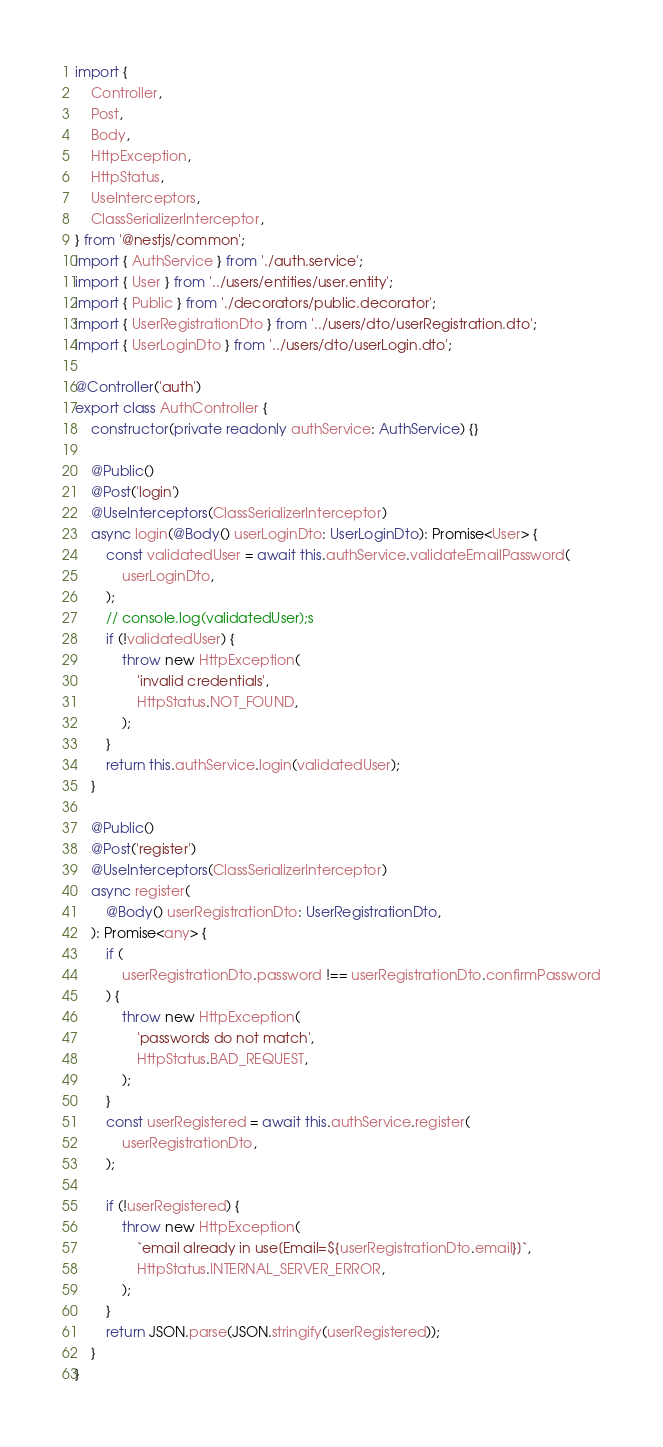<code> <loc_0><loc_0><loc_500><loc_500><_TypeScript_>import {
    Controller,
    Post,
    Body,
    HttpException,
    HttpStatus,
    UseInterceptors,
    ClassSerializerInterceptor,
} from '@nestjs/common';
import { AuthService } from './auth.service';
import { User } from '../users/entities/user.entity';
import { Public } from './decorators/public.decorator';
import { UserRegistrationDto } from '../users/dto/userRegistration.dto';
import { UserLoginDto } from '../users/dto/userLogin.dto';

@Controller('auth')
export class AuthController {
    constructor(private readonly authService: AuthService) {}

    @Public()
    @Post('login')
    @UseInterceptors(ClassSerializerInterceptor)
    async login(@Body() userLoginDto: UserLoginDto): Promise<User> {
        const validatedUser = await this.authService.validateEmailPassword(
            userLoginDto,
        );
        // console.log(validatedUser);s
        if (!validatedUser) {
            throw new HttpException(
                'invalid credentials',
                HttpStatus.NOT_FOUND,
            );
        }
        return this.authService.login(validatedUser);
    }

    @Public()
    @Post('register')
    @UseInterceptors(ClassSerializerInterceptor)
    async register(
        @Body() userRegistrationDto: UserRegistrationDto,
    ): Promise<any> {
        if (
            userRegistrationDto.password !== userRegistrationDto.confirmPassword
        ) {
            throw new HttpException(
                'passwords do not match',
                HttpStatus.BAD_REQUEST,
            );
        }
        const userRegistered = await this.authService.register(
            userRegistrationDto,
        );

        if (!userRegistered) {
            throw new HttpException(
                `email already in use[Email=${userRegistrationDto.email}]`,
                HttpStatus.INTERNAL_SERVER_ERROR,
            );
        }
        return JSON.parse(JSON.stringify(userRegistered));
    }
}
</code> 